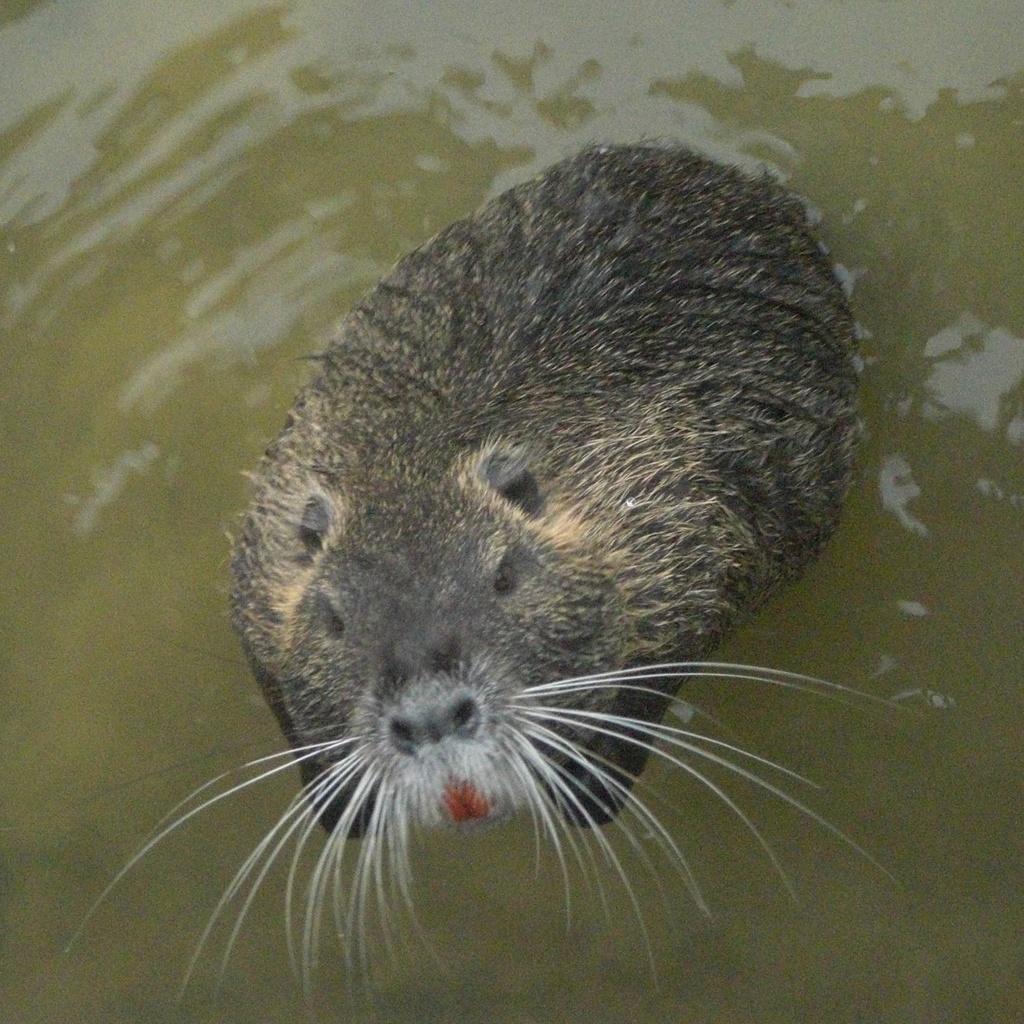Please provide a concise description of this image. In this picture I can see there is a rat swimming in the water and it has mustache. 